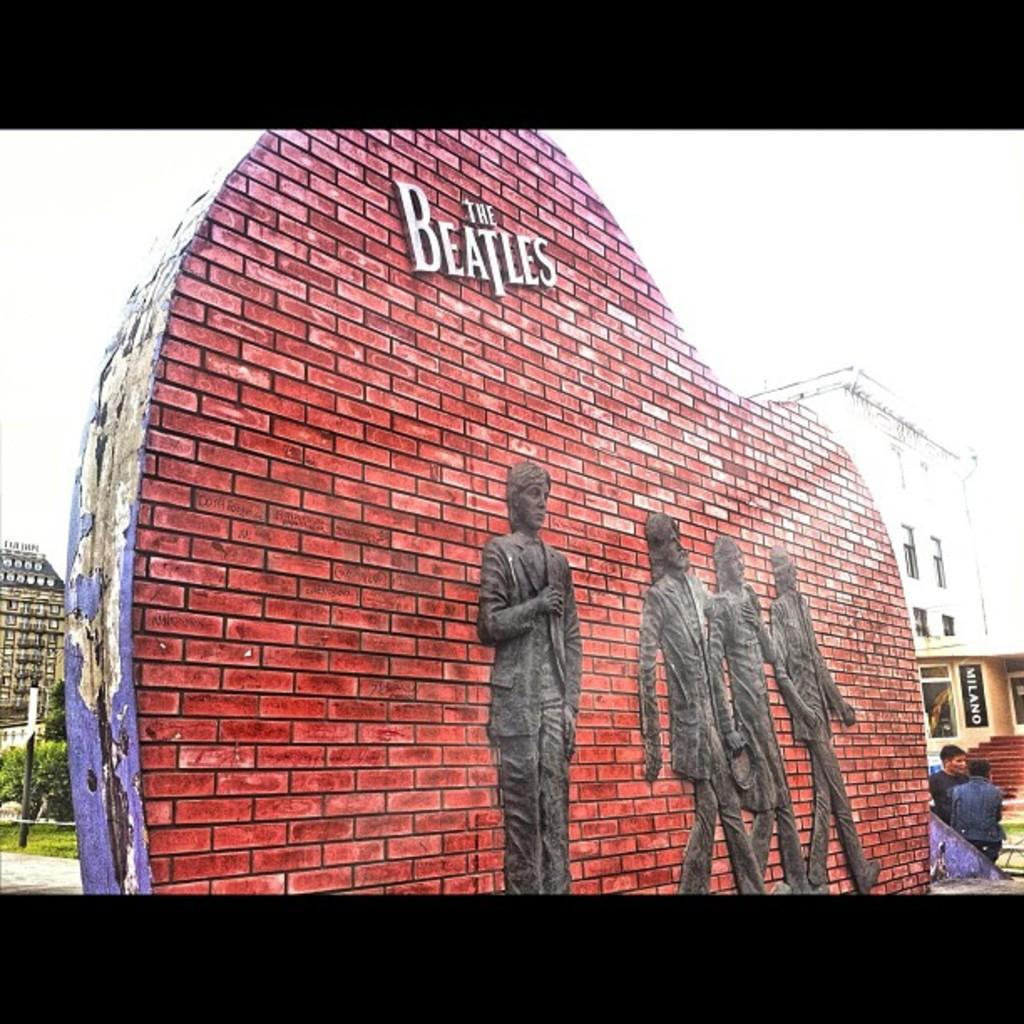What is the main subject of the image? The main subject of the image is a brick wall with images and text. What else can be seen in the background of the image? There are buildings and trees visible in the image. Are there any living beings in the image? Yes, there are people in the image. How many pigs are present in the image? There are no pigs present in the image. What is the best way to reach the location depicted in the image? The image does not provide information about how to reach the location, so it cannot be determined from the image. 